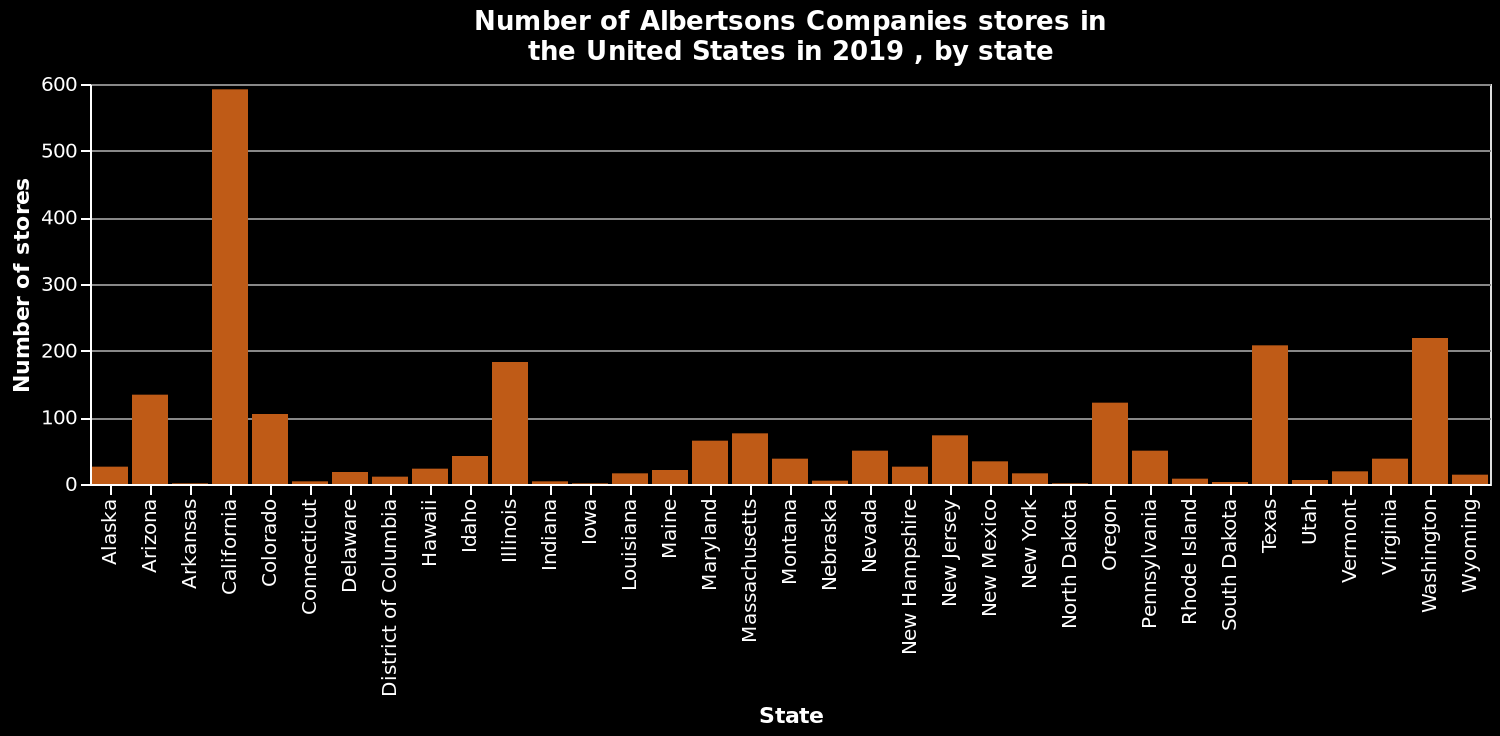<image>
What state had the highest number of Albertsons Companies stores in 2019?  The state with the highest number of Albertsons Companies stores in 2019 is not provided in the description. 